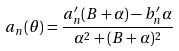Convert formula to latex. <formula><loc_0><loc_0><loc_500><loc_500>a _ { n } ( \theta ) = \frac { a _ { n } ^ { \prime } ( B + \alpha ) - b _ { n } ^ { \prime } \alpha } { \alpha ^ { 2 } + ( B + \alpha ) ^ { 2 } }</formula> 